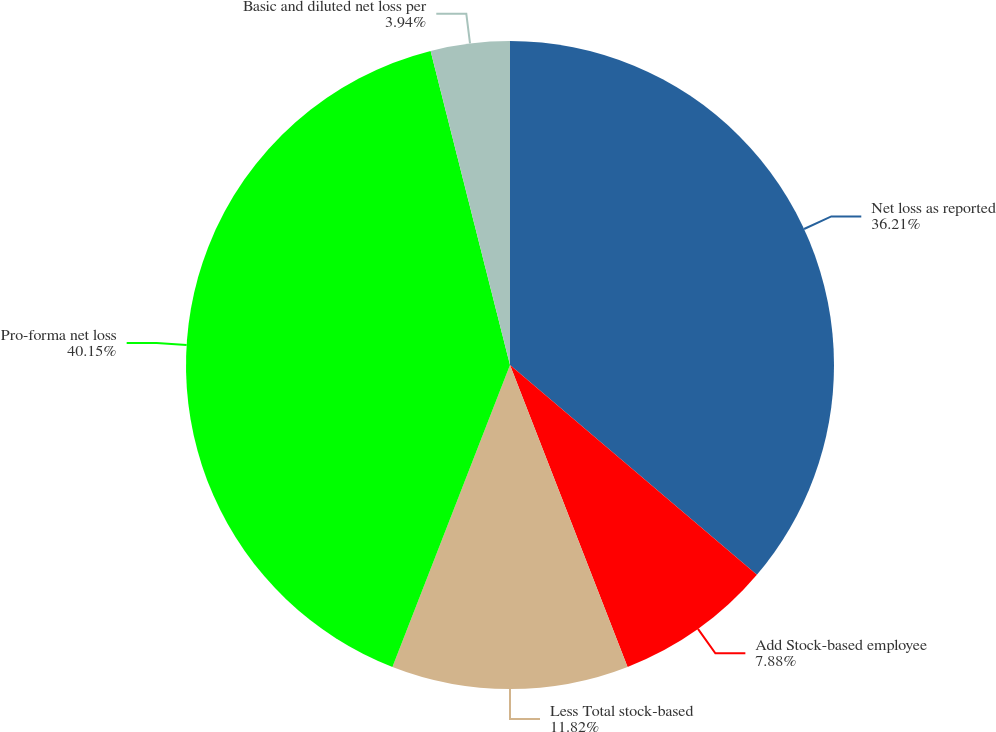<chart> <loc_0><loc_0><loc_500><loc_500><pie_chart><fcel>Net loss as reported<fcel>Add Stock-based employee<fcel>Less Total stock-based<fcel>Pro-forma net loss<fcel>Basic and diluted net loss per<nl><fcel>36.21%<fcel>7.88%<fcel>11.82%<fcel>40.15%<fcel>3.94%<nl></chart> 